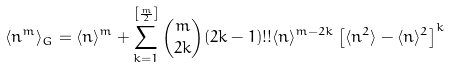Convert formula to latex. <formula><loc_0><loc_0><loc_500><loc_500>\langle n ^ { m } \rangle _ { G } = \langle n \rangle ^ { m } + \sum _ { k = 1 } ^ { \left [ \frac { m } { 2 } \right ] } { m \choose 2 k } ( 2 k - 1 ) ! ! \langle n \rangle ^ { m - 2 k } \left [ \langle n ^ { 2 } \rangle - \langle n \rangle ^ { 2 } \right ] ^ { k }</formula> 